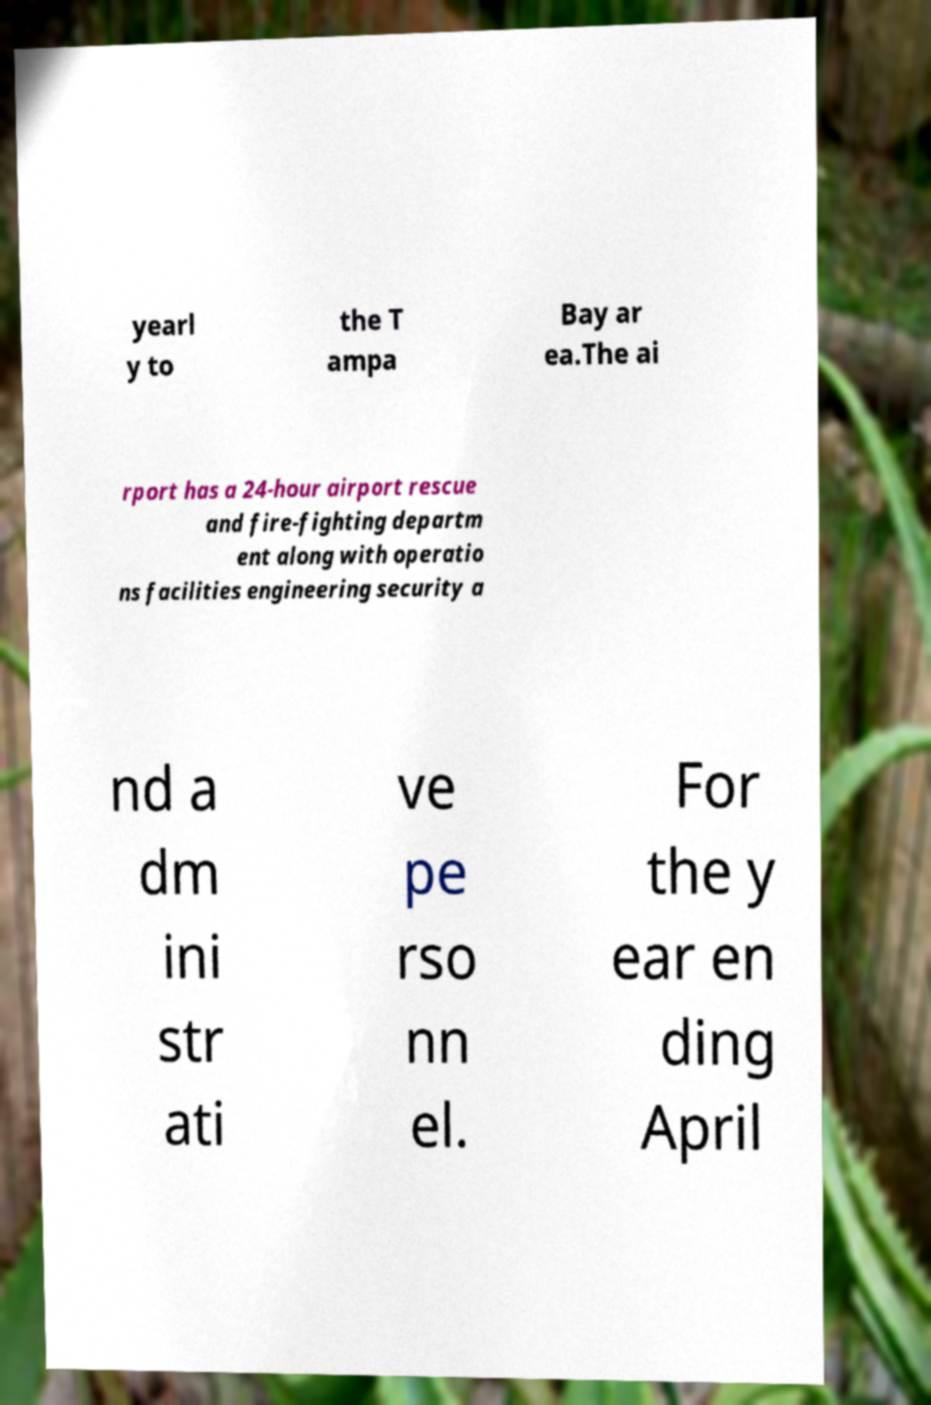Can you read and provide the text displayed in the image?This photo seems to have some interesting text. Can you extract and type it out for me? yearl y to the T ampa Bay ar ea.The ai rport has a 24-hour airport rescue and fire-fighting departm ent along with operatio ns facilities engineering security a nd a dm ini str ati ve pe rso nn el. For the y ear en ding April 